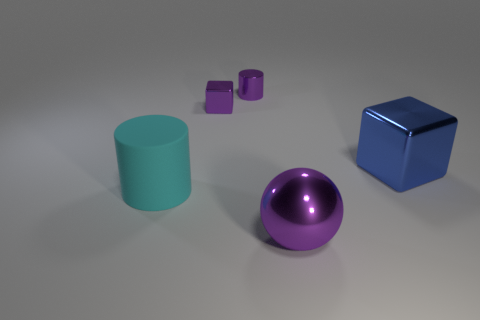Add 1 small brown metal cylinders. How many objects exist? 6 Subtract all cubes. How many objects are left? 3 Add 2 yellow objects. How many yellow objects exist? 2 Subtract 1 purple cylinders. How many objects are left? 4 Subtract all brown metal blocks. Subtract all purple cylinders. How many objects are left? 4 Add 5 large blue metal blocks. How many large blue metal blocks are left? 6 